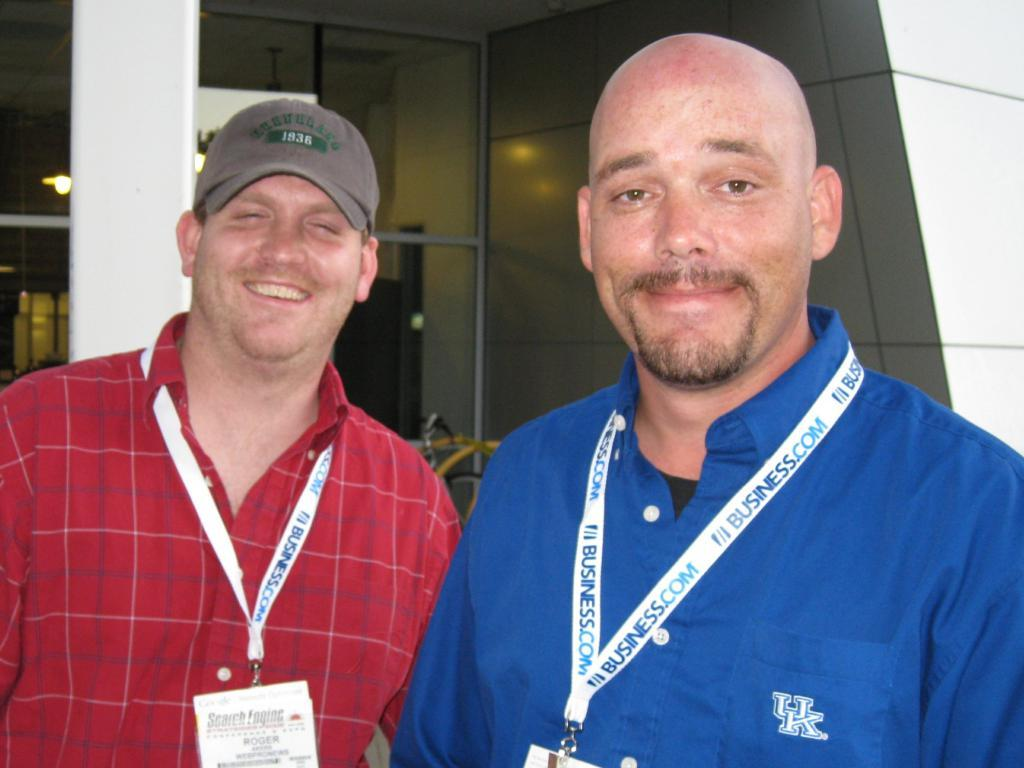<image>
Offer a succinct explanation of the picture presented. Tow men smile for a picture both wearing lanyards that say business.com 